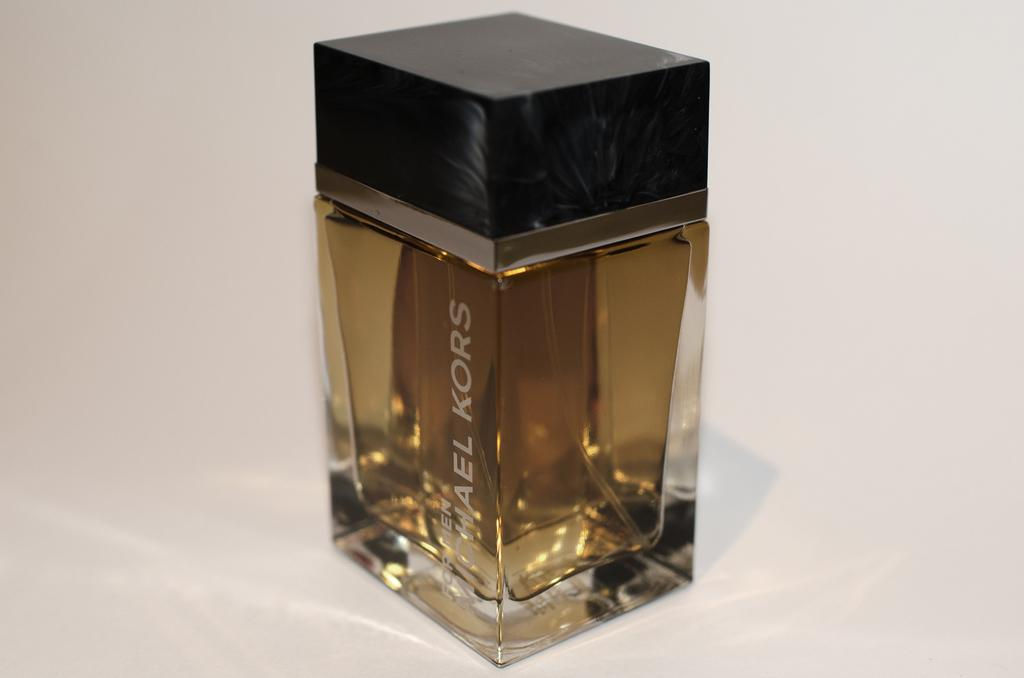<image>
Write a terse but informative summary of the picture. Bottle of Michael Kors cologne by itself on a table 